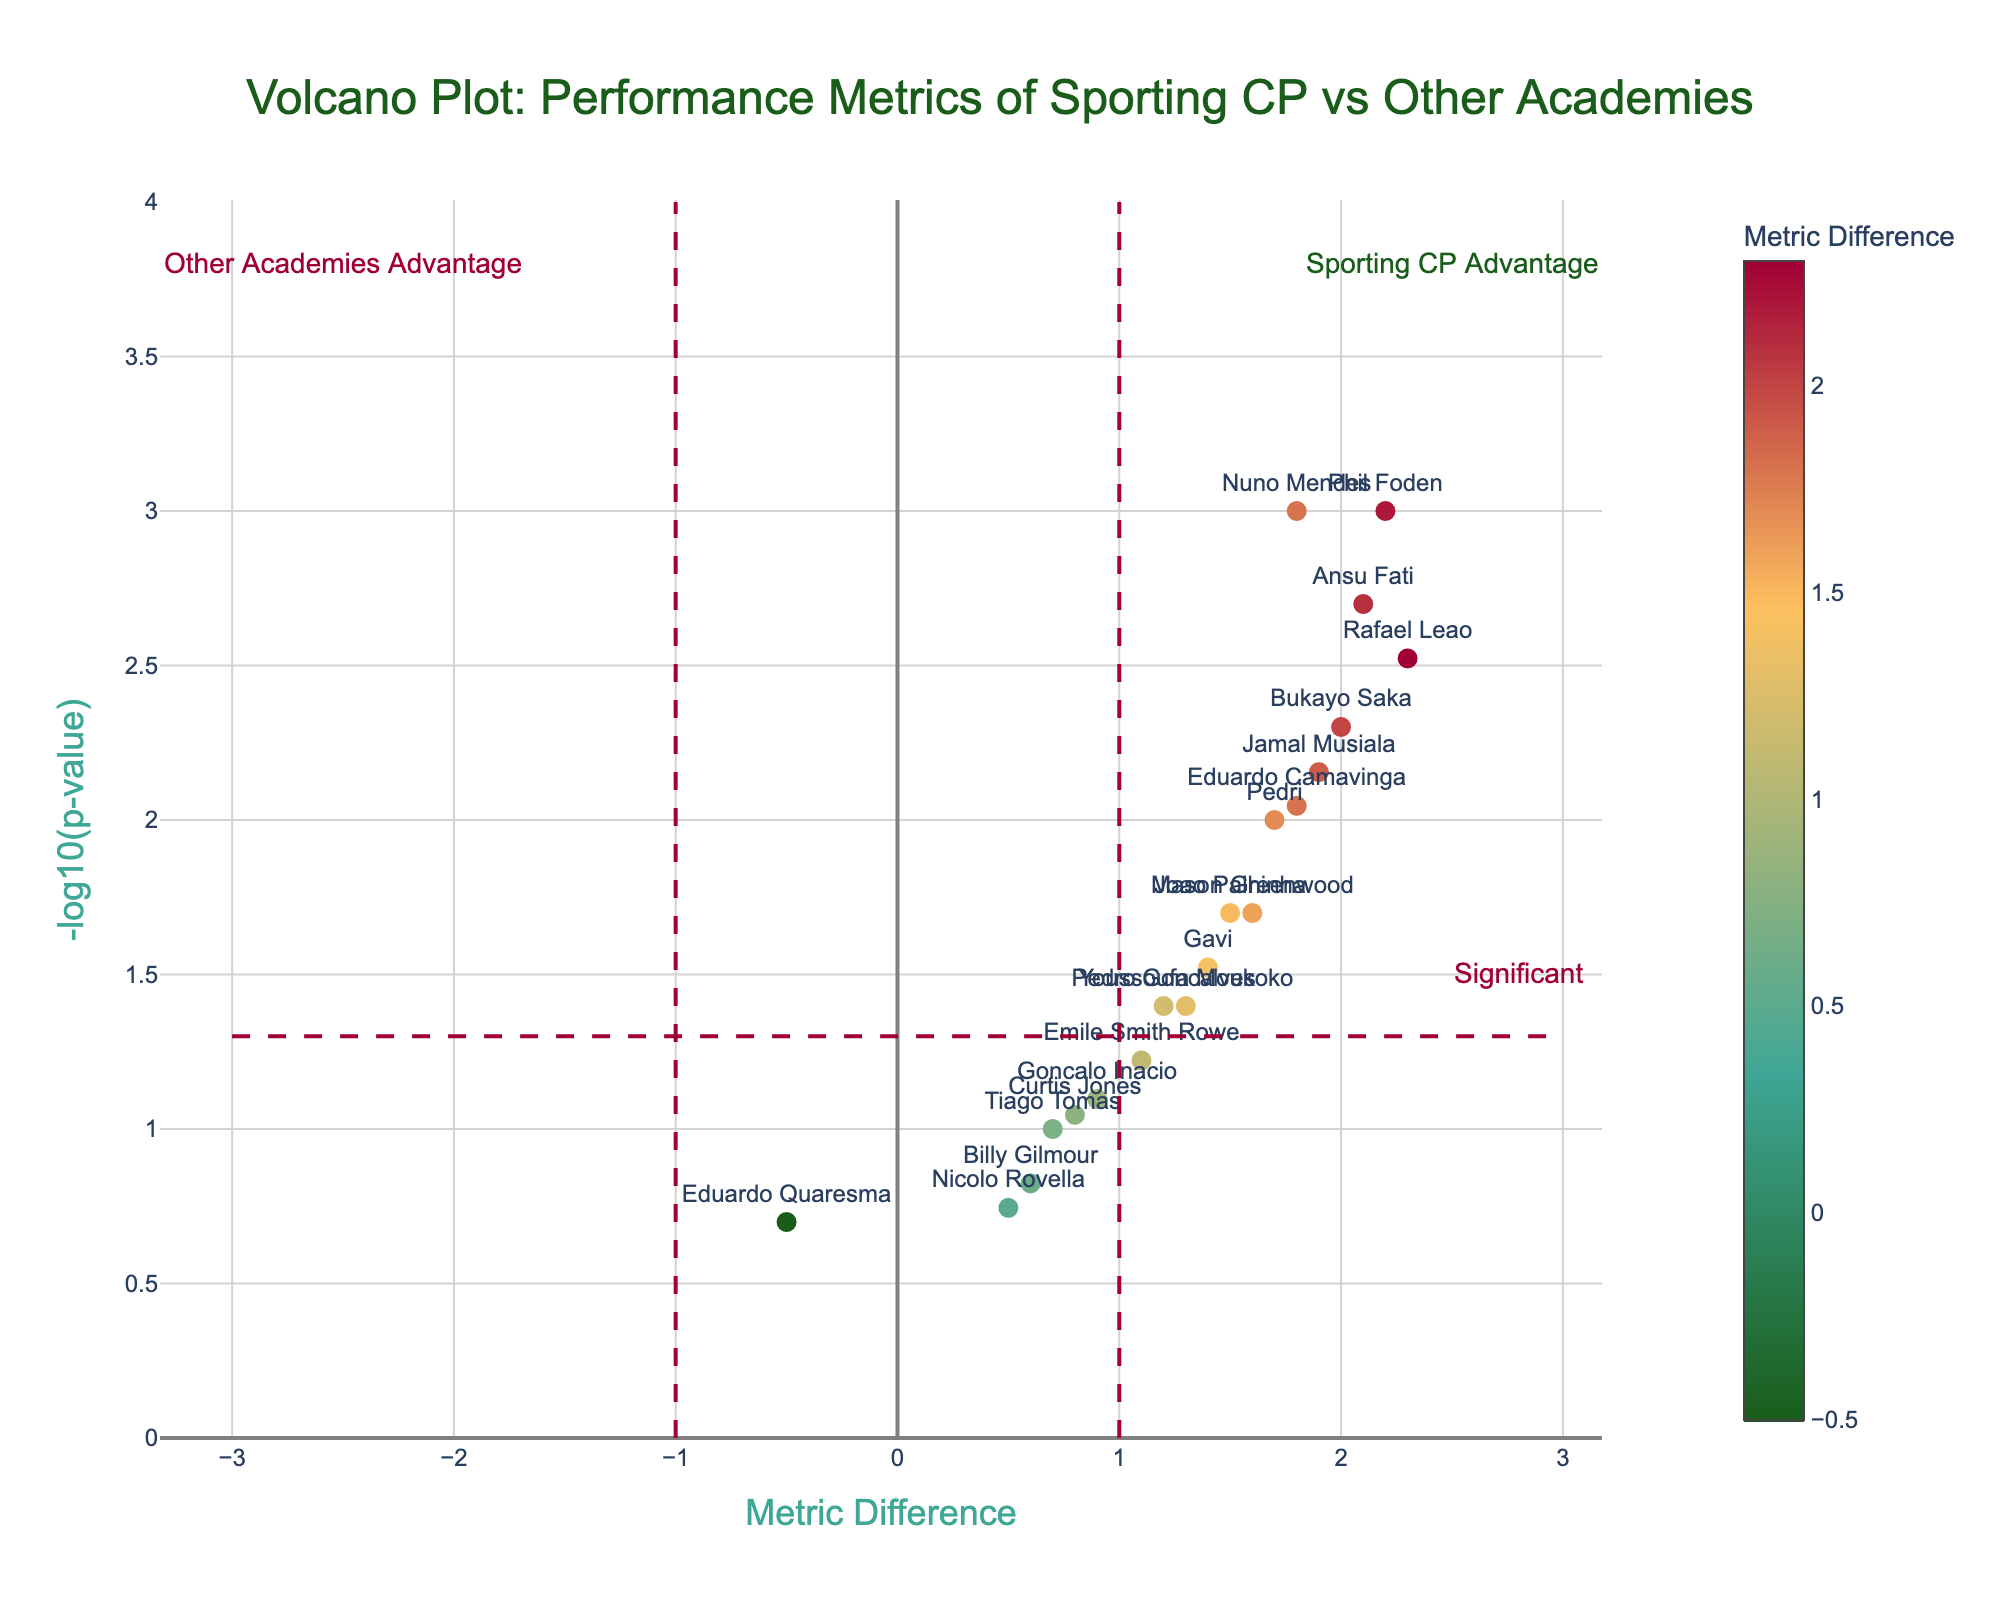Is a metric difference of 1.5 considered significant in the plot? A metric difference is considered significant if the -log10(p-value) is greater than 1.3. We see Joao Palhinha with a metric difference of 1.5 and a -log10(p-value) greater than 1.3. Thus, it is significant.
Answer: Yes How many players from Sporting CP have significant p-values? A significant p-value is indicated by a -log10(p-value) greater than 1.3. The Sporting CP players with significant p-values are Nuno Mendes, Rafael Leao, Joao Palhinha, and Pedro Goncalves.
Answer: 4 Which player from Sporting CP has the highest metric difference? By examining the metric differences for Sporting CP players, Rafael Leao has the highest with a value of 2.3.
Answer: Rafael Leao Compare the metric difference and p-value of Nuno Mendes (Sporting CP) and Ansu Fati (Barcelona). Nuno Mendes has a metric difference of 1.8 and a -log10(p-value) of -log10(0.001). Ansu Fati has a metric difference of 2.1 and a -log10(p-value) of -log10(0.002). The metric difference for Ansu Fati is higher, and both have significant p-values.
Answer: Ansu Fati has a higher metric Among the Sporting CP players, who has the lowest metric difference, and is it significant? Eduardo Quaresma has the lowest metric difference of -0.5 among Sporting CP players. His p-value is 0.2, which translates to a -log10(p-value) less than 1.3, making it not significant.
Answer: Eduardo Quaresma, not significant Are there any players with negative metric differences? By looking at the x-axis, Eduardo Quaresma from Sporting CP has a metric difference of -0.5, indicating a negative value.
Answer: Yes, Eduardo Quaresma What is the highest -log10(p-value) in the plot, and which player does it belong to? The highest -log10(p-value) in the plot is represented by Nuno Mendes from Sporting CP with a -log10(p-value) of -log10(0.001).
Answer: Nuno Mendes How many players have a metric difference greater than 2.0? Players with a metric difference greater than 2.0 include Rafael Leao (Sporting CP), Ansu Fati (Barcelona), Bukayo Saka (Arsenal), and Phil Foden (Manchester City).
Answer: 4 Which player from Barcelona has the highest metric difference and is it significant? Ansu Fati has the highest metric difference (2.1) among Barcelona players and a significant -log10(p-value) greater than 1.3.
Answer: Ansu Fati, significant 